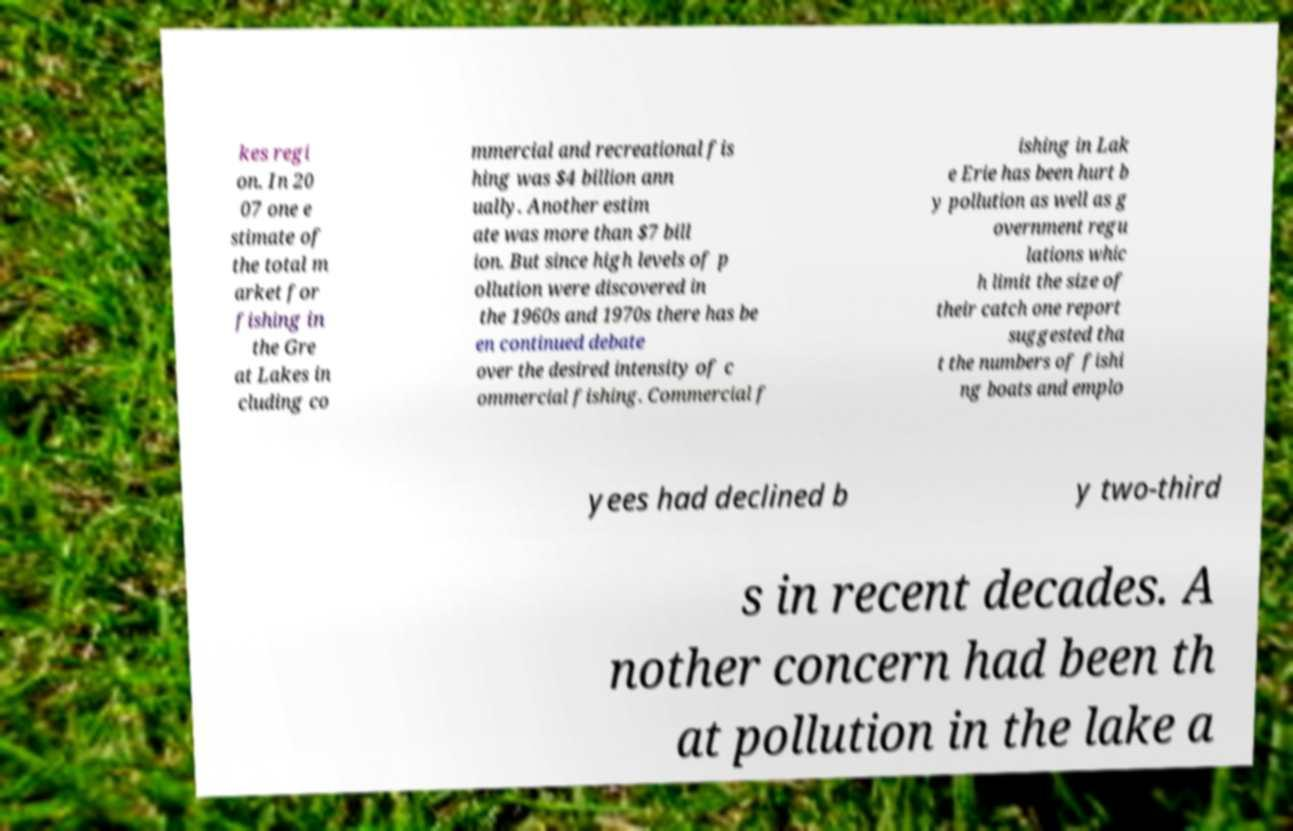There's text embedded in this image that I need extracted. Can you transcribe it verbatim? kes regi on. In 20 07 one e stimate of the total m arket for fishing in the Gre at Lakes in cluding co mmercial and recreational fis hing was $4 billion ann ually. Another estim ate was more than $7 bill ion. But since high levels of p ollution were discovered in the 1960s and 1970s there has be en continued debate over the desired intensity of c ommercial fishing. Commercial f ishing in Lak e Erie has been hurt b y pollution as well as g overnment regu lations whic h limit the size of their catch one report suggested tha t the numbers of fishi ng boats and emplo yees had declined b y two-third s in recent decades. A nother concern had been th at pollution in the lake a 